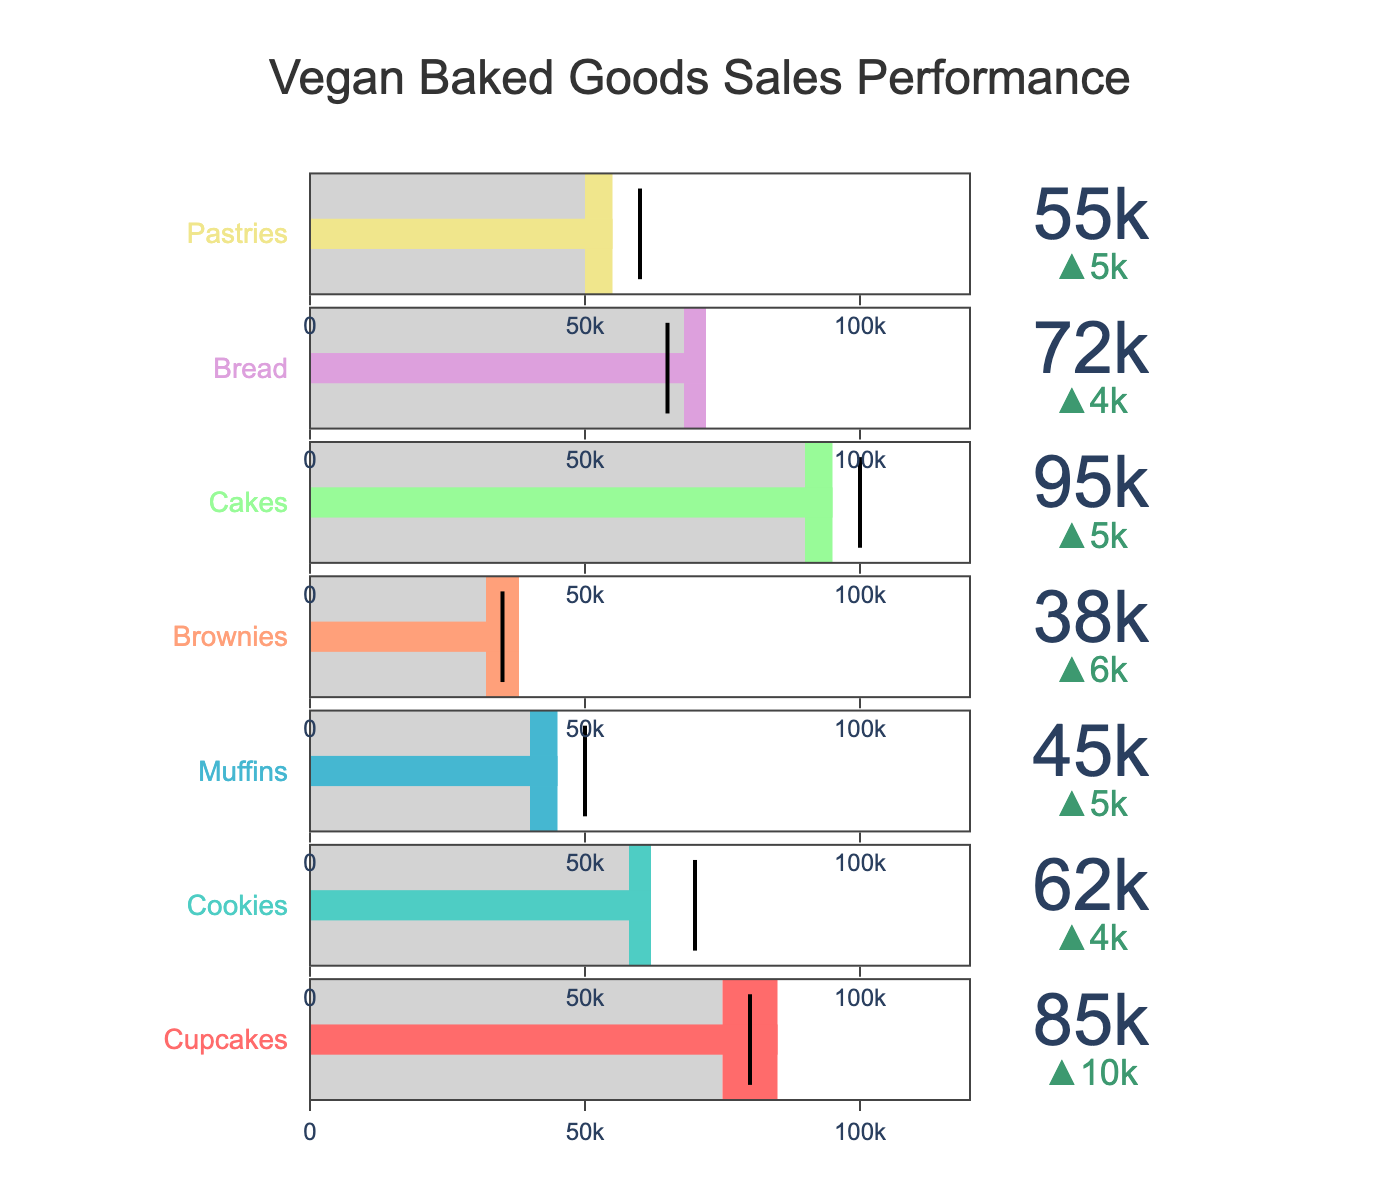What is the title of the bullet chart? The title is usually prominently displayed at the top of the chart. In this case, it describes the overall subject of the data visualization.
Answer: Vegan Baked Goods Sales Performance How many product categories are shown in the chart? By counting the number of distinct categories listed in the chart, we can determine the number of product categories.
Answer: Seven Which product category has the highest actual sales? Look for the category with the longest bar indicating actual sales.
Answer: Cakes For which product category did the actual sales exceed the target sales? Compare the actual sales bar to the target line for each product category.
Answer: Cupcakes, Brownies, and Bread Which product category shows a decline from the previous year's sales? Check the delta indicator to find any negative changes compared to the previous year's sales.
Answer: Pastries What is the difference between the target and actual sales for Cakes? Subtract the target sales from the actual sales for Cakes: 95000 - 100000.
Answer: -5000 Is the actual sales value for Cookies higher or lower than the target sales? Compare the actual sales bar to the target line for Cookies.
Answer: Lower What is the collective actual sales for Cupcakes, Muffins, and Brownies? Sum the actual sales values for the three categories: 85000 + 45000 + 38000.
Answer: 168000 How much did Bread sales improve from the previous year? Subtract the previous year sales from the actual sales for Bread: 72000 - 68000.
Answer: 4000 Which product category's actual sales is closest to its target sales? Look for the category where the actual sales bar is closest to the target line.
Answer: Pastries 